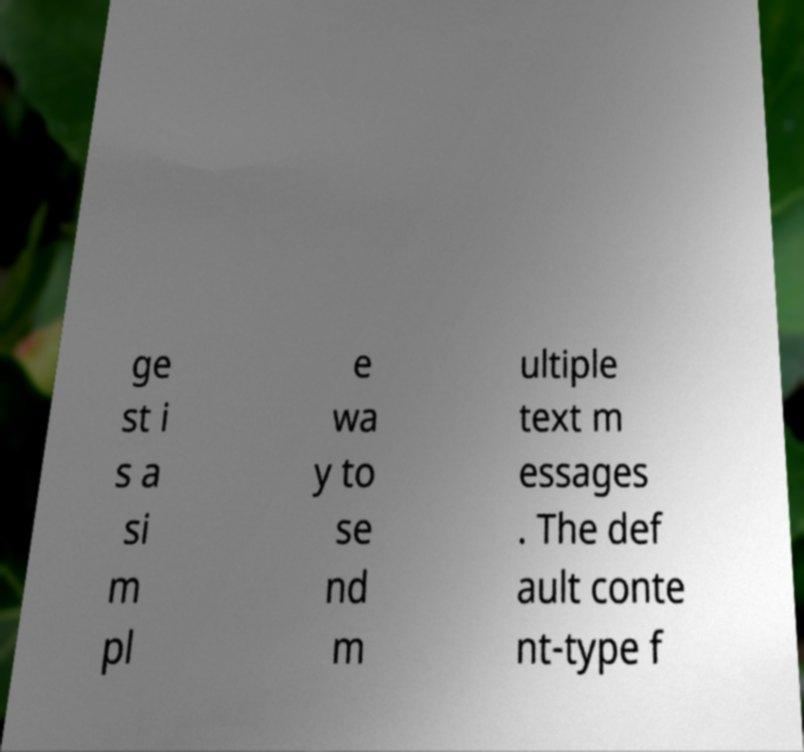Please identify and transcribe the text found in this image. ge st i s a si m pl e wa y to se nd m ultiple text m essages . The def ault conte nt-type f 